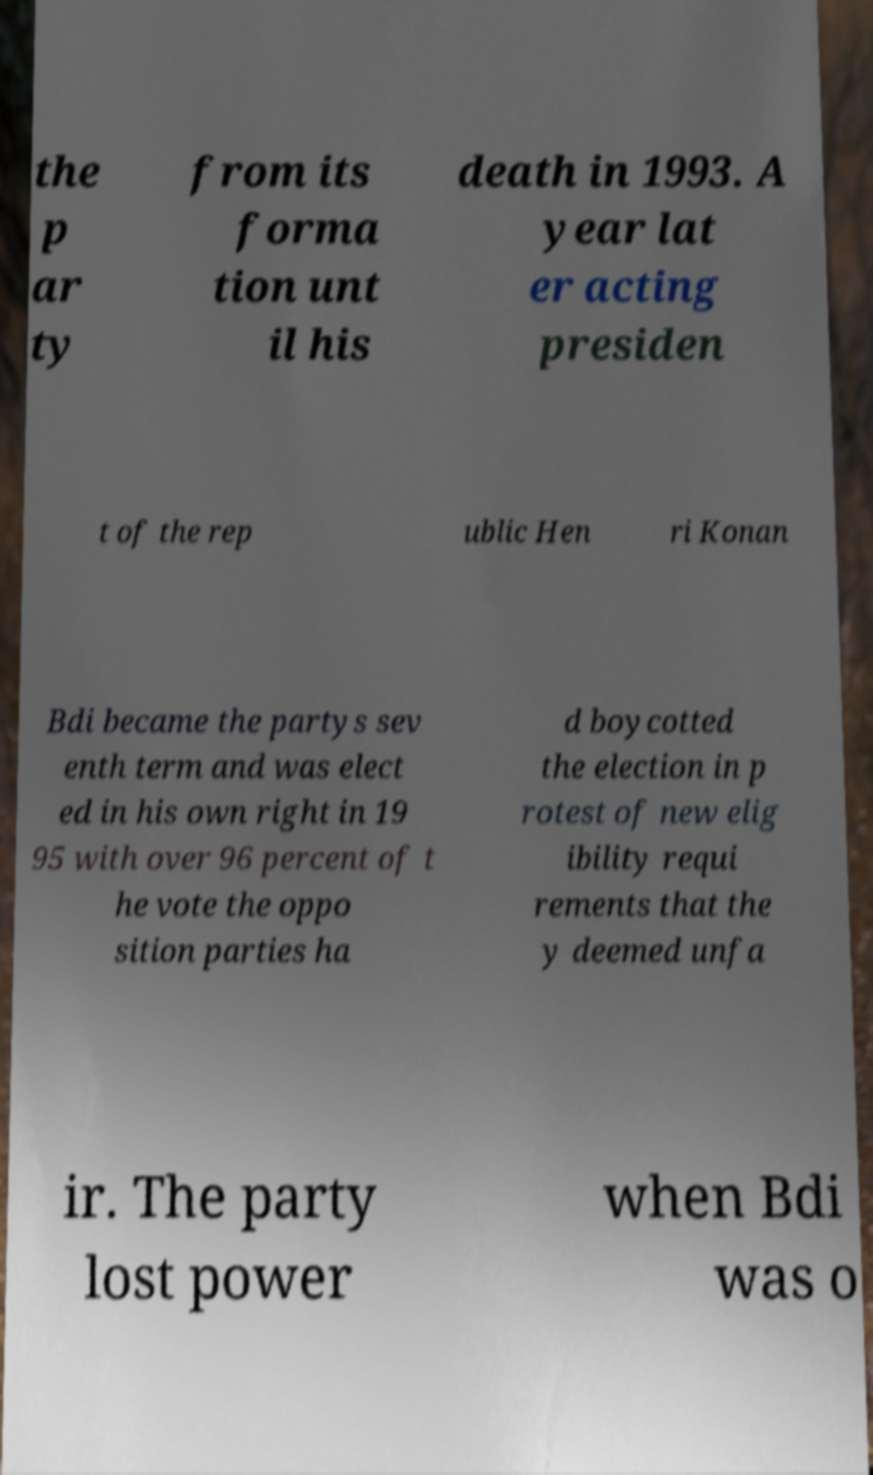Could you assist in decoding the text presented in this image and type it out clearly? the p ar ty from its forma tion unt il his death in 1993. A year lat er acting presiden t of the rep ublic Hen ri Konan Bdi became the partys sev enth term and was elect ed in his own right in 19 95 with over 96 percent of t he vote the oppo sition parties ha d boycotted the election in p rotest of new elig ibility requi rements that the y deemed unfa ir. The party lost power when Bdi was o 